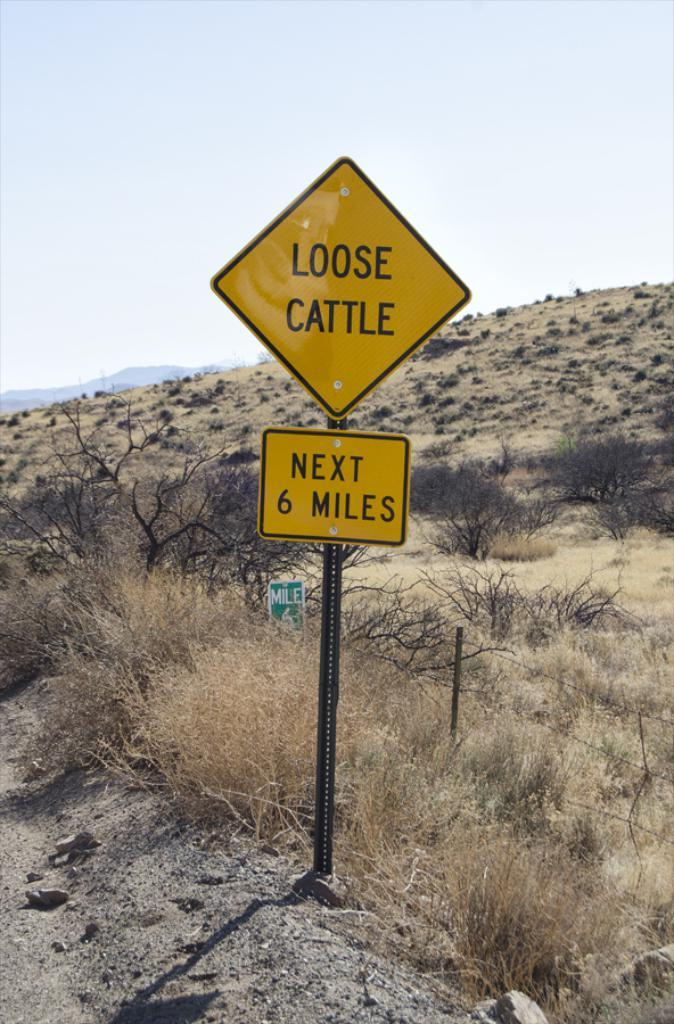<image>
Provide a brief description of the given image. Diamond shaped yellow sign for any loose cattle 